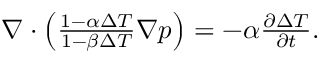Convert formula to latex. <formula><loc_0><loc_0><loc_500><loc_500>\begin{array} { r } { \nabla \cdot \left ( \frac { 1 - \alpha \Delta T } { 1 - \beta \Delta T } \nabla p \right ) = - \alpha \frac { \partial \Delta T } { \partial t } . } \end{array}</formula> 